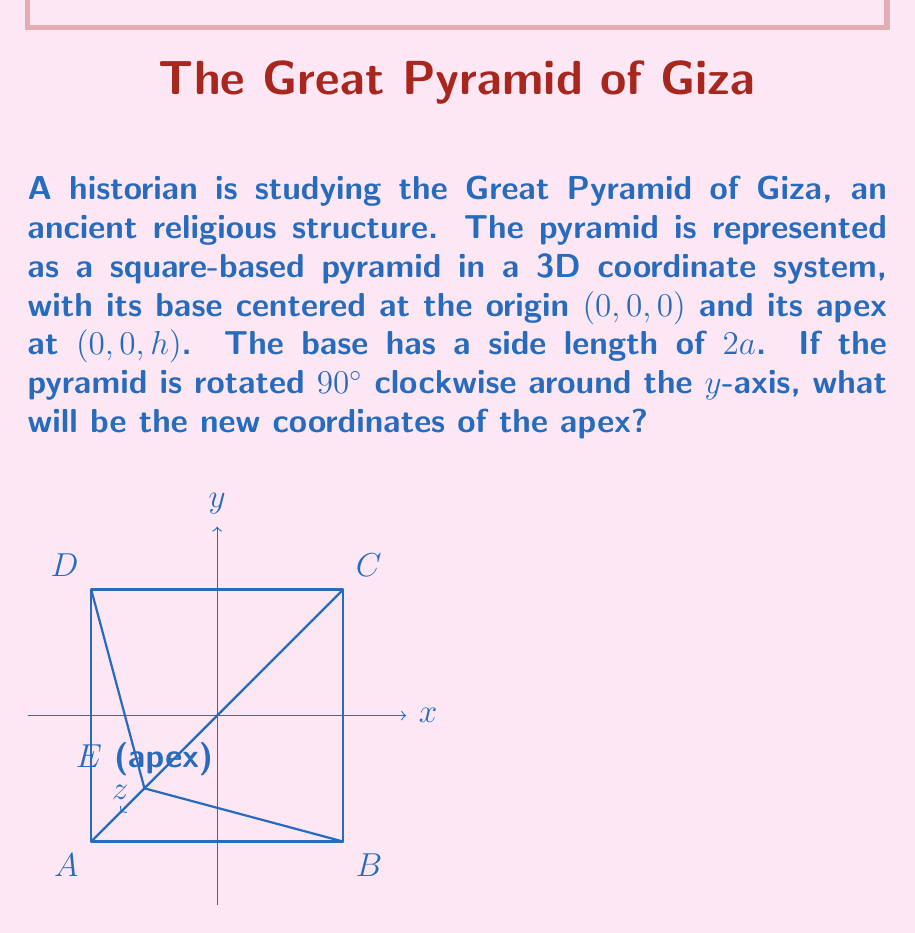Give your solution to this math problem. Let's approach this step-by-step:

1) Initially, the apex is at (0, 0, h).

2) A 90° clockwise rotation around the y-axis can be represented by the following transformation matrix:

   $$\begin{pmatrix}
   0 & 0 & 1 \\
   0 & 1 & 0 \\
   -1 & 0 & 0
   \end{pmatrix}$$

3) To find the new coordinates, we multiply this matrix by the initial coordinates:

   $$\begin{pmatrix}
   0 & 0 & 1 \\
   0 & 1 & 0 \\
   -1 & 0 & 0
   \end{pmatrix} \times
   \begin{pmatrix}
   0 \\
   0 \\
   h
   \end{pmatrix} =
   \begin{pmatrix}
   h \\
   0 \\
   0
   \end{pmatrix}$$

4) This matrix multiplication results in:
   
   $x' = 1 \times h = h$
   $y' = 0$
   $z' = 0$

Therefore, after the rotation, the new coordinates of the apex will be (h, 0, 0).
Answer: (h, 0, 0) 